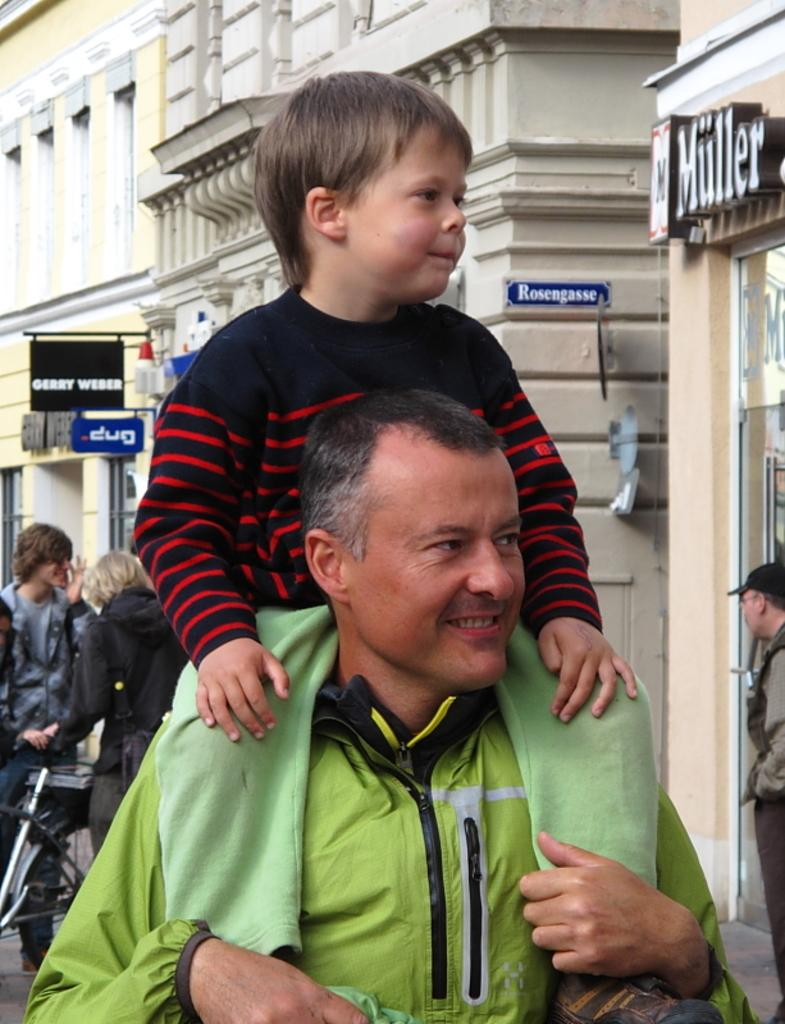Who is the main subject in the image? There is a man in the image. What is the man doing in the image? The man is carrying a kid on his shoulders. Is the man interacting with anyone else in the image? Yes, the man is looking at someone. What type of knot is the man using to secure the sail in the image? There is no sail or knot present in the image; it features a man carrying a kid on his shoulders and looking at someone. 